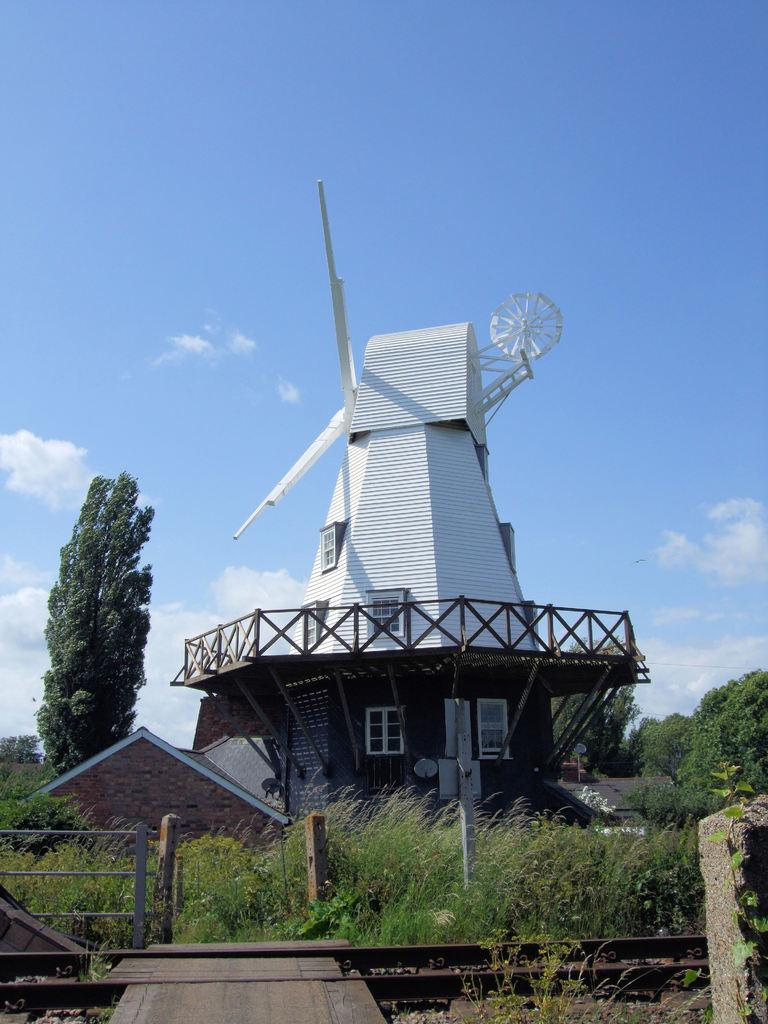What is the main feature in the image? There is a track in the image. What can be seen in the background of the image? There is grass, a turbine, trees, and the sky visible in the background of the image. What type of wool is being used to create the icicles in the image? There are no icicles present in the image, and wool is not mentioned or visible. 